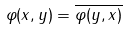<formula> <loc_0><loc_0><loc_500><loc_500>\varphi ( x , y ) = \overline { \varphi ( y , x ) }</formula> 